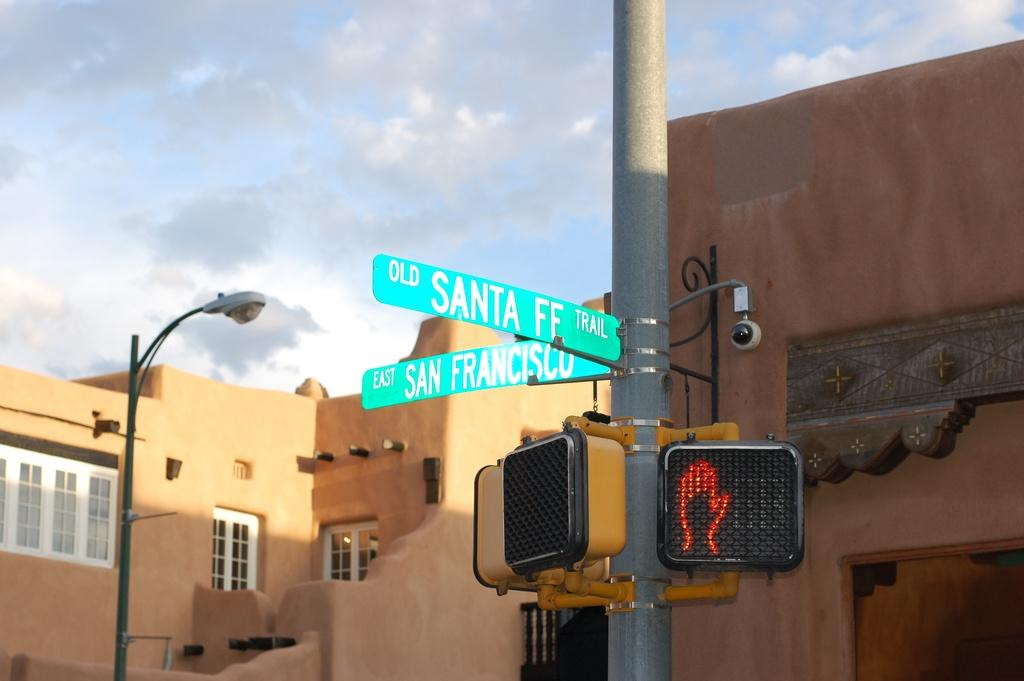What is attached to the pole in the image? There are name boards and signals attached to a pole in the image. What type of lighting is present in the image? There is a street light in the image. What can be seen on the buildings in the image? There are buildings with windows in the image. What is visible in the background of the image? The sky with clouds is visible in the background of the image. What type of animal can be seen crossing the road in the image? There is no road or animal present in the image. What time of day is depicted in the image? The time of day cannot be determined from the image, as there are no specific indicators of time. 